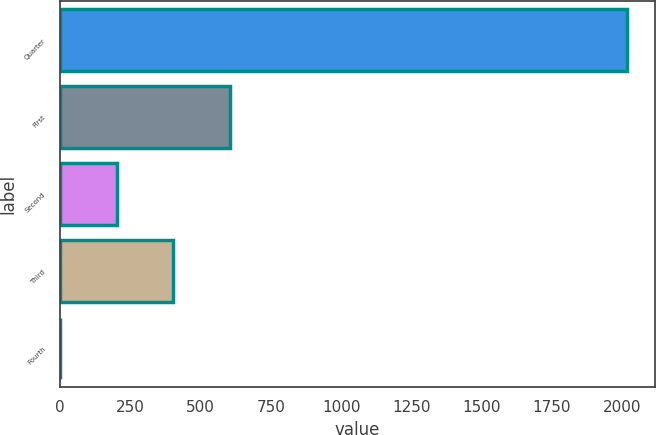Convert chart to OTSL. <chart><loc_0><loc_0><loc_500><loc_500><bar_chart><fcel>Quarter<fcel>First<fcel>Second<fcel>Third<fcel>Fourth<nl><fcel>2017<fcel>605.46<fcel>202.16<fcel>403.81<fcel>0.51<nl></chart> 